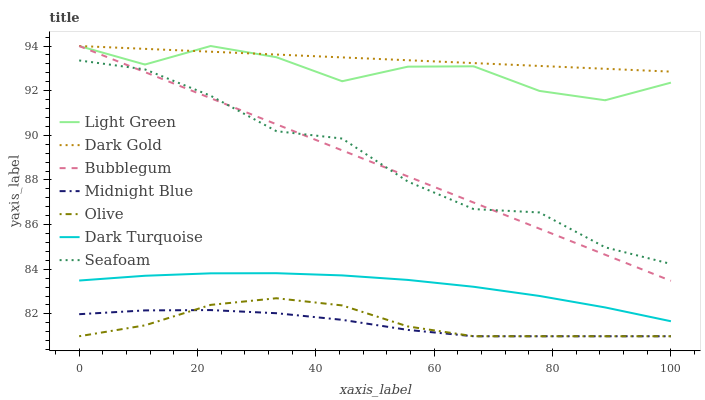Does Dark Turquoise have the minimum area under the curve?
Answer yes or no. No. Does Dark Turquoise have the maximum area under the curve?
Answer yes or no. No. Is Dark Gold the smoothest?
Answer yes or no. No. Is Dark Gold the roughest?
Answer yes or no. No. Does Dark Turquoise have the lowest value?
Answer yes or no. No. Does Dark Turquoise have the highest value?
Answer yes or no. No. Is Dark Turquoise less than Bubblegum?
Answer yes or no. Yes. Is Seafoam greater than Olive?
Answer yes or no. Yes. Does Dark Turquoise intersect Bubblegum?
Answer yes or no. No. 